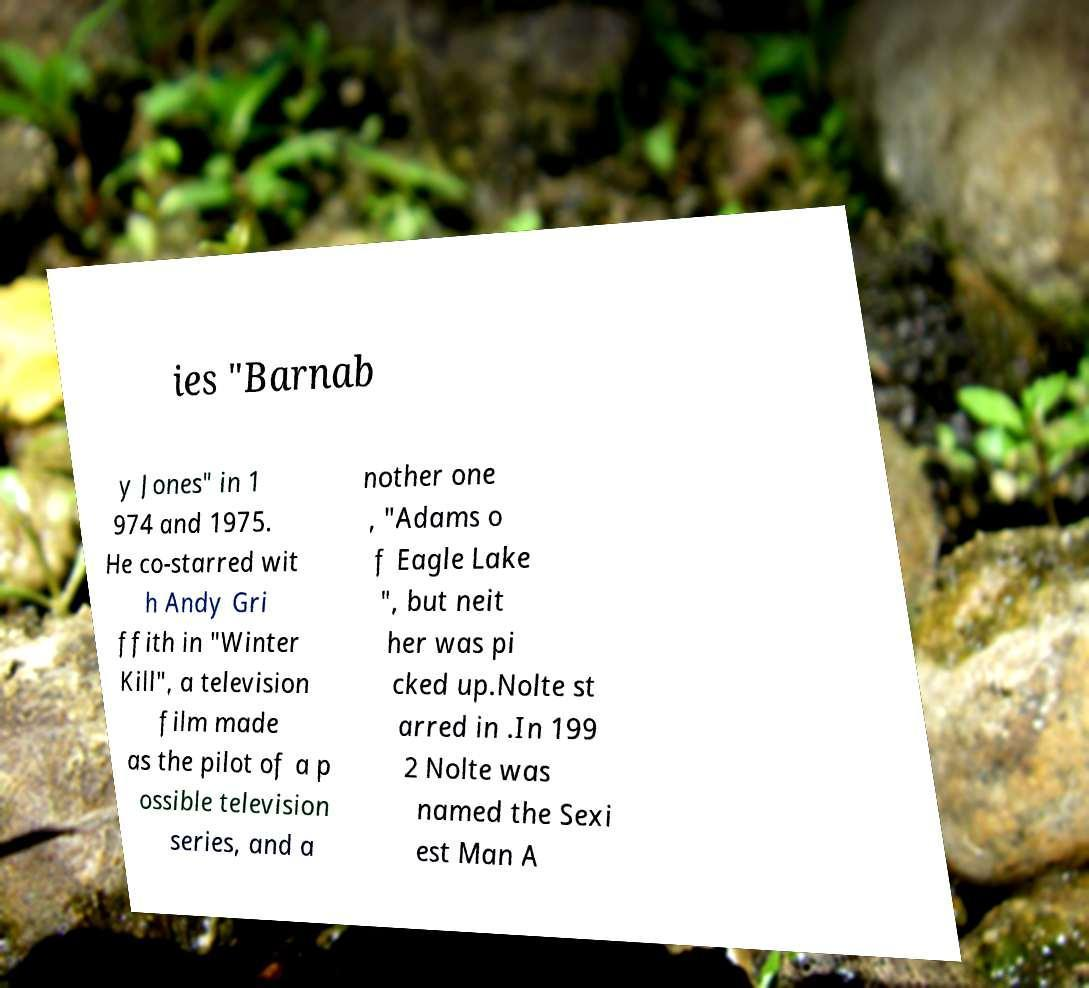Could you assist in decoding the text presented in this image and type it out clearly? ies "Barnab y Jones" in 1 974 and 1975. He co-starred wit h Andy Gri ffith in "Winter Kill", a television film made as the pilot of a p ossible television series, and a nother one , "Adams o f Eagle Lake ", but neit her was pi cked up.Nolte st arred in .In 199 2 Nolte was named the Sexi est Man A 